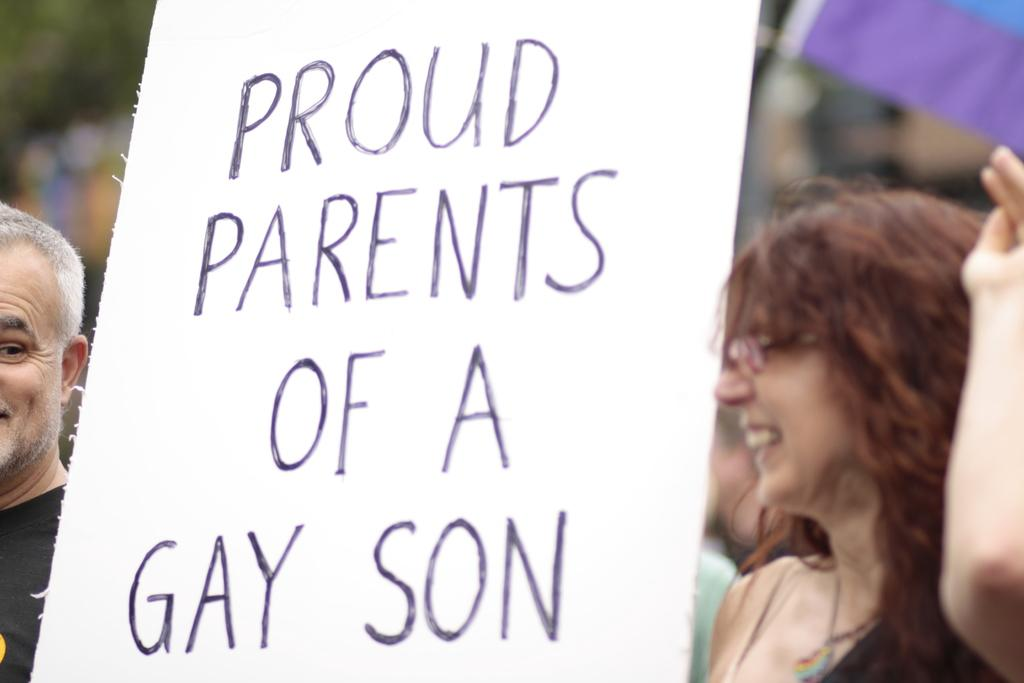How many people are present in the image? There are two people, a man and a woman, present in the image. What are the man and woman doing in the image? The man and woman are standing in the image. What can be seen on the board in the image? There is text on the board in the image. What is the additional object visible in the image? There is a flag in the image. Can you describe the background of the image? It appears that there are people standing in the background. What type of drink is the man holding in the image? There is no drink visible in the image; the man is not holding anything. 